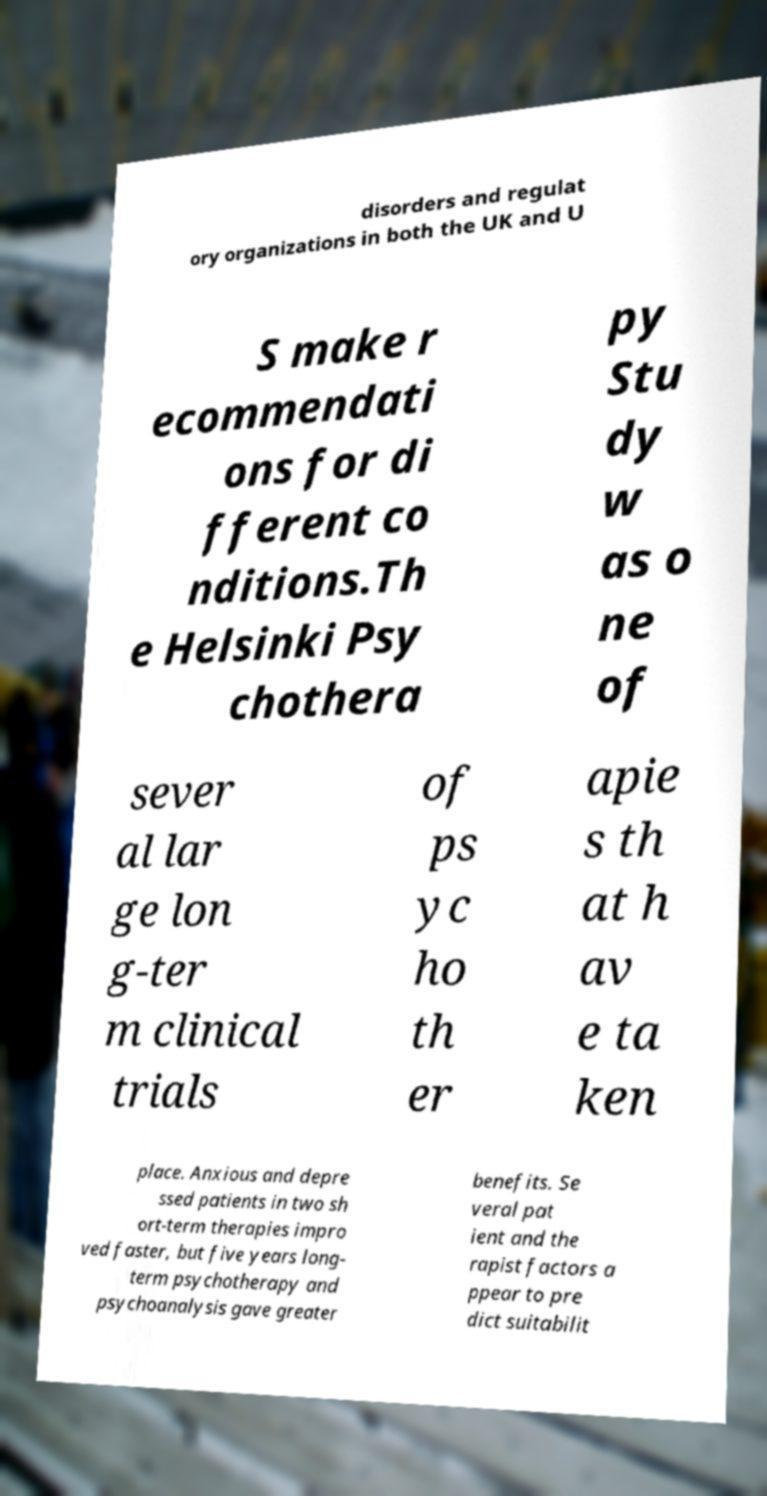Can you accurately transcribe the text from the provided image for me? disorders and regulat ory organizations in both the UK and U S make r ecommendati ons for di fferent co nditions.Th e Helsinki Psy chothera py Stu dy w as o ne of sever al lar ge lon g-ter m clinical trials of ps yc ho th er apie s th at h av e ta ken place. Anxious and depre ssed patients in two sh ort-term therapies impro ved faster, but five years long- term psychotherapy and psychoanalysis gave greater benefits. Se veral pat ient and the rapist factors a ppear to pre dict suitabilit 